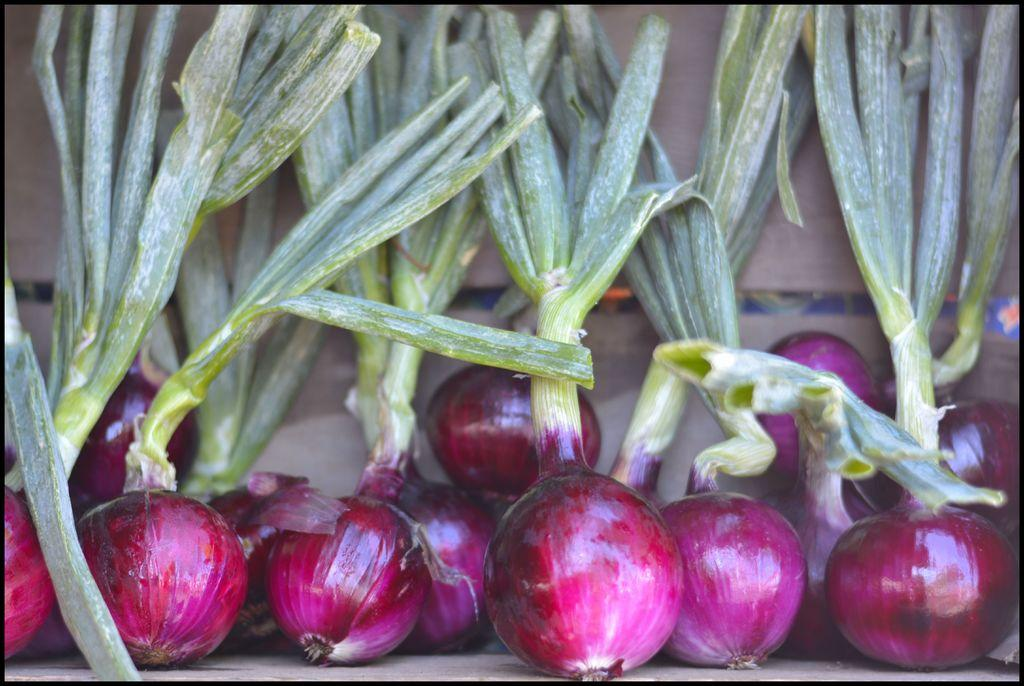What type of vegetable is present in the image? There are onions with leaves in the image. Where are the onions located? The onions are kept on the floor. What can be seen in the background of the image? There is a wall visible in the background of the image. What type of face can be seen on the quince in the image? There is no quince or face present in the image; it features onions with leaves on the floor and a wall in the background. 